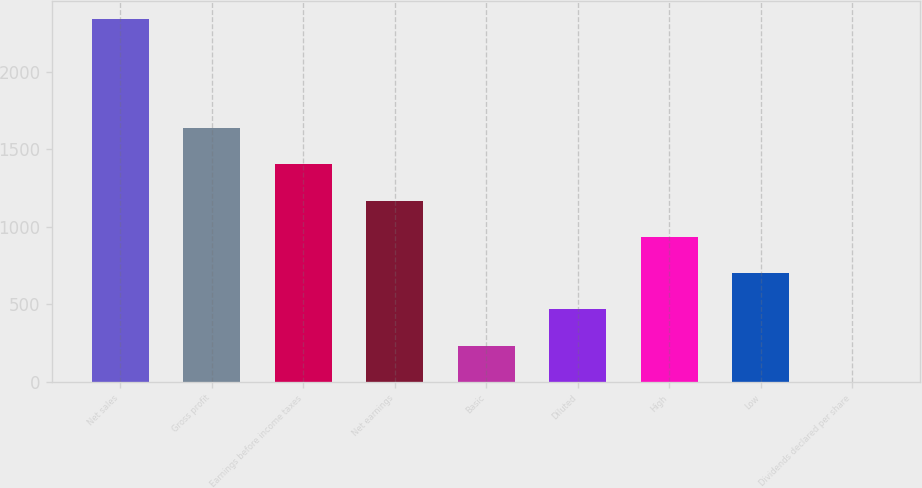Convert chart. <chart><loc_0><loc_0><loc_500><loc_500><bar_chart><fcel>Net sales<fcel>Gross profit<fcel>Earnings before income taxes<fcel>Net earnings<fcel>Basic<fcel>Diluted<fcel>High<fcel>Low<fcel>Dividends declared per share<nl><fcel>2337<fcel>1635.96<fcel>1402.29<fcel>1168.62<fcel>233.94<fcel>467.61<fcel>934.95<fcel>701.28<fcel>0.27<nl></chart> 